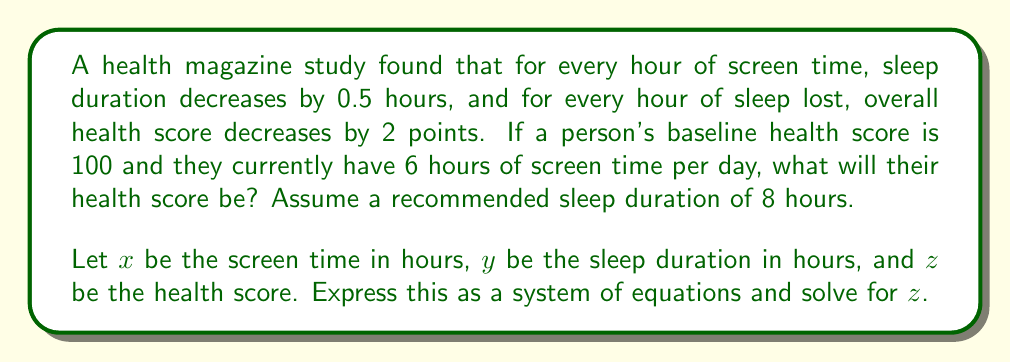Provide a solution to this math problem. Let's approach this step-by-step:

1) First, we can express the relationship between screen time and sleep duration:
   $$y = 8 - 0.5x$$

2) Next, we can express the relationship between sleep loss and health score:
   $$z = 100 - 2(8 - y)$$

3) Substitute the first equation into the second:
   $$z = 100 - 2(8 - (8 - 0.5x))$$

4) Simplify:
   $$z = 100 - 2(0.5x)$$
   $$z = 100 - x$$

5) Now we have a direct relationship between screen time and health score.

6) Given that the person has 6 hours of screen time:
   $$z = 100 - 6$$

7) Solve for $z$:
   $$z = 94$$

Therefore, with 6 hours of screen time, the person's health score will be 94.
Answer: 94 